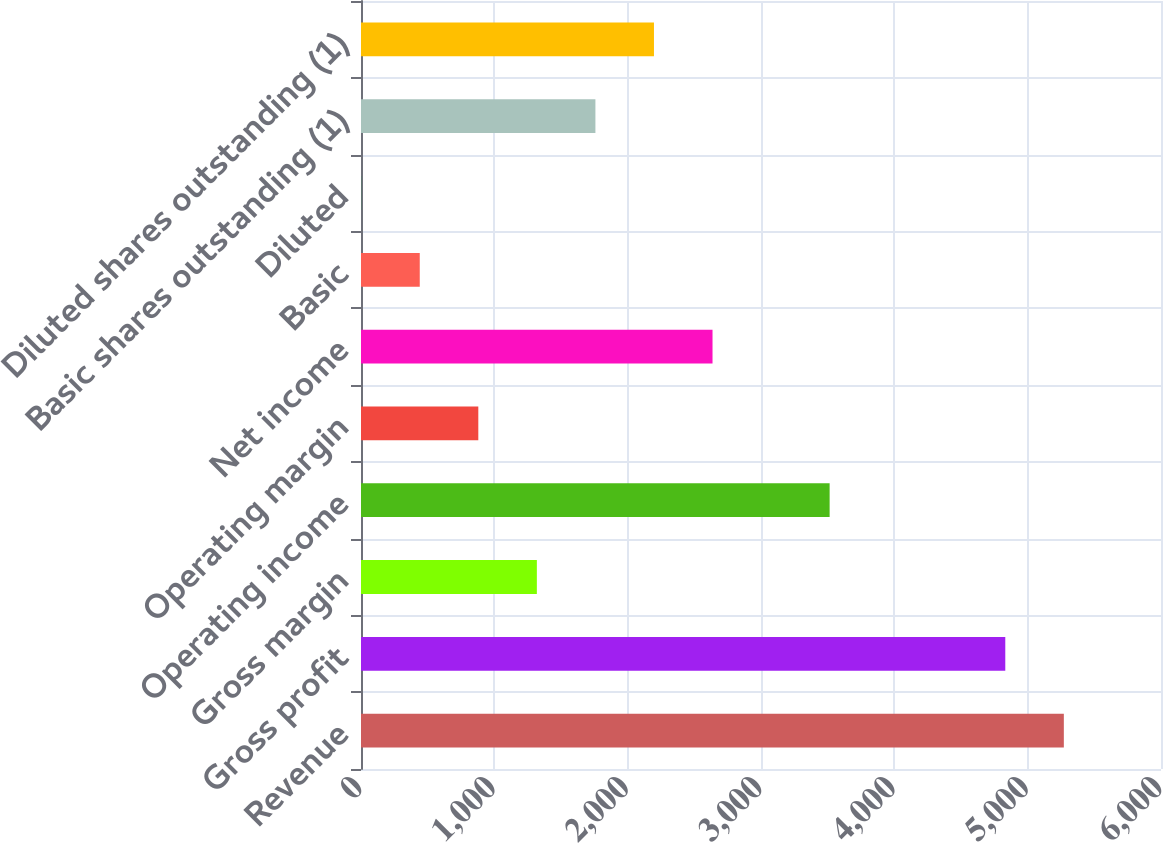<chart> <loc_0><loc_0><loc_500><loc_500><bar_chart><fcel>Revenue<fcel>Gross profit<fcel>Gross margin<fcel>Operating income<fcel>Operating margin<fcel>Net income<fcel>Basic<fcel>Diluted<fcel>Basic shares outstanding (1)<fcel>Diluted shares outstanding (1)<nl><fcel>5271.3<fcel>4832.15<fcel>1318.95<fcel>3514.7<fcel>879.8<fcel>2636.4<fcel>440.65<fcel>1.5<fcel>1758.1<fcel>2197.25<nl></chart> 